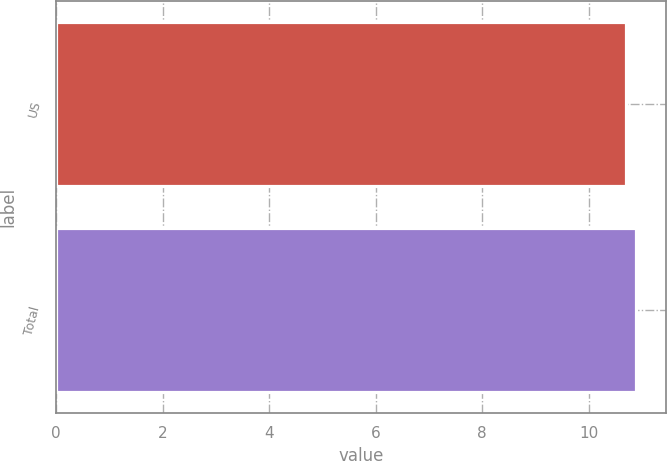Convert chart to OTSL. <chart><loc_0><loc_0><loc_500><loc_500><bar_chart><fcel>US<fcel>Total<nl><fcel>10.7<fcel>10.9<nl></chart> 